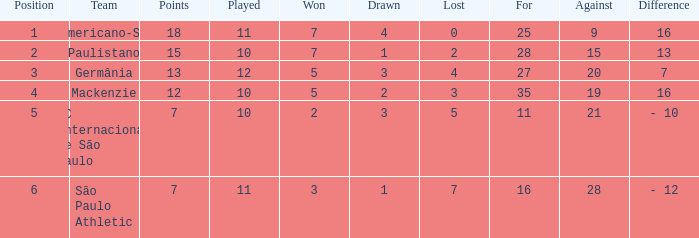Help me parse the entirety of this table. {'header': ['Position', 'Team', 'Points', 'Played', 'Won', 'Drawn', 'Lost', 'For', 'Against', 'Difference'], 'rows': [['1', 'Americano-SP', '18', '11', '7', '4', '0', '25', '9', '16'], ['2', 'Paulistano', '15', '10', '7', '1', '2', '28', '15', '13'], ['3', 'Germânia', '13', '12', '5', '3', '4', '27', '20', '7'], ['4', 'Mackenzie', '12', '10', '5', '2', '3', '35', '19', '16'], ['5', 'SC Internacional de São Paulo', '7', '10', '2', '3', '5', '11', '21', '- 10'], ['6', 'São Paulo Athletic', '7', '11', '3', '1', '7', '16', '28', '- 12']]} Name the points for paulistano 15.0. 